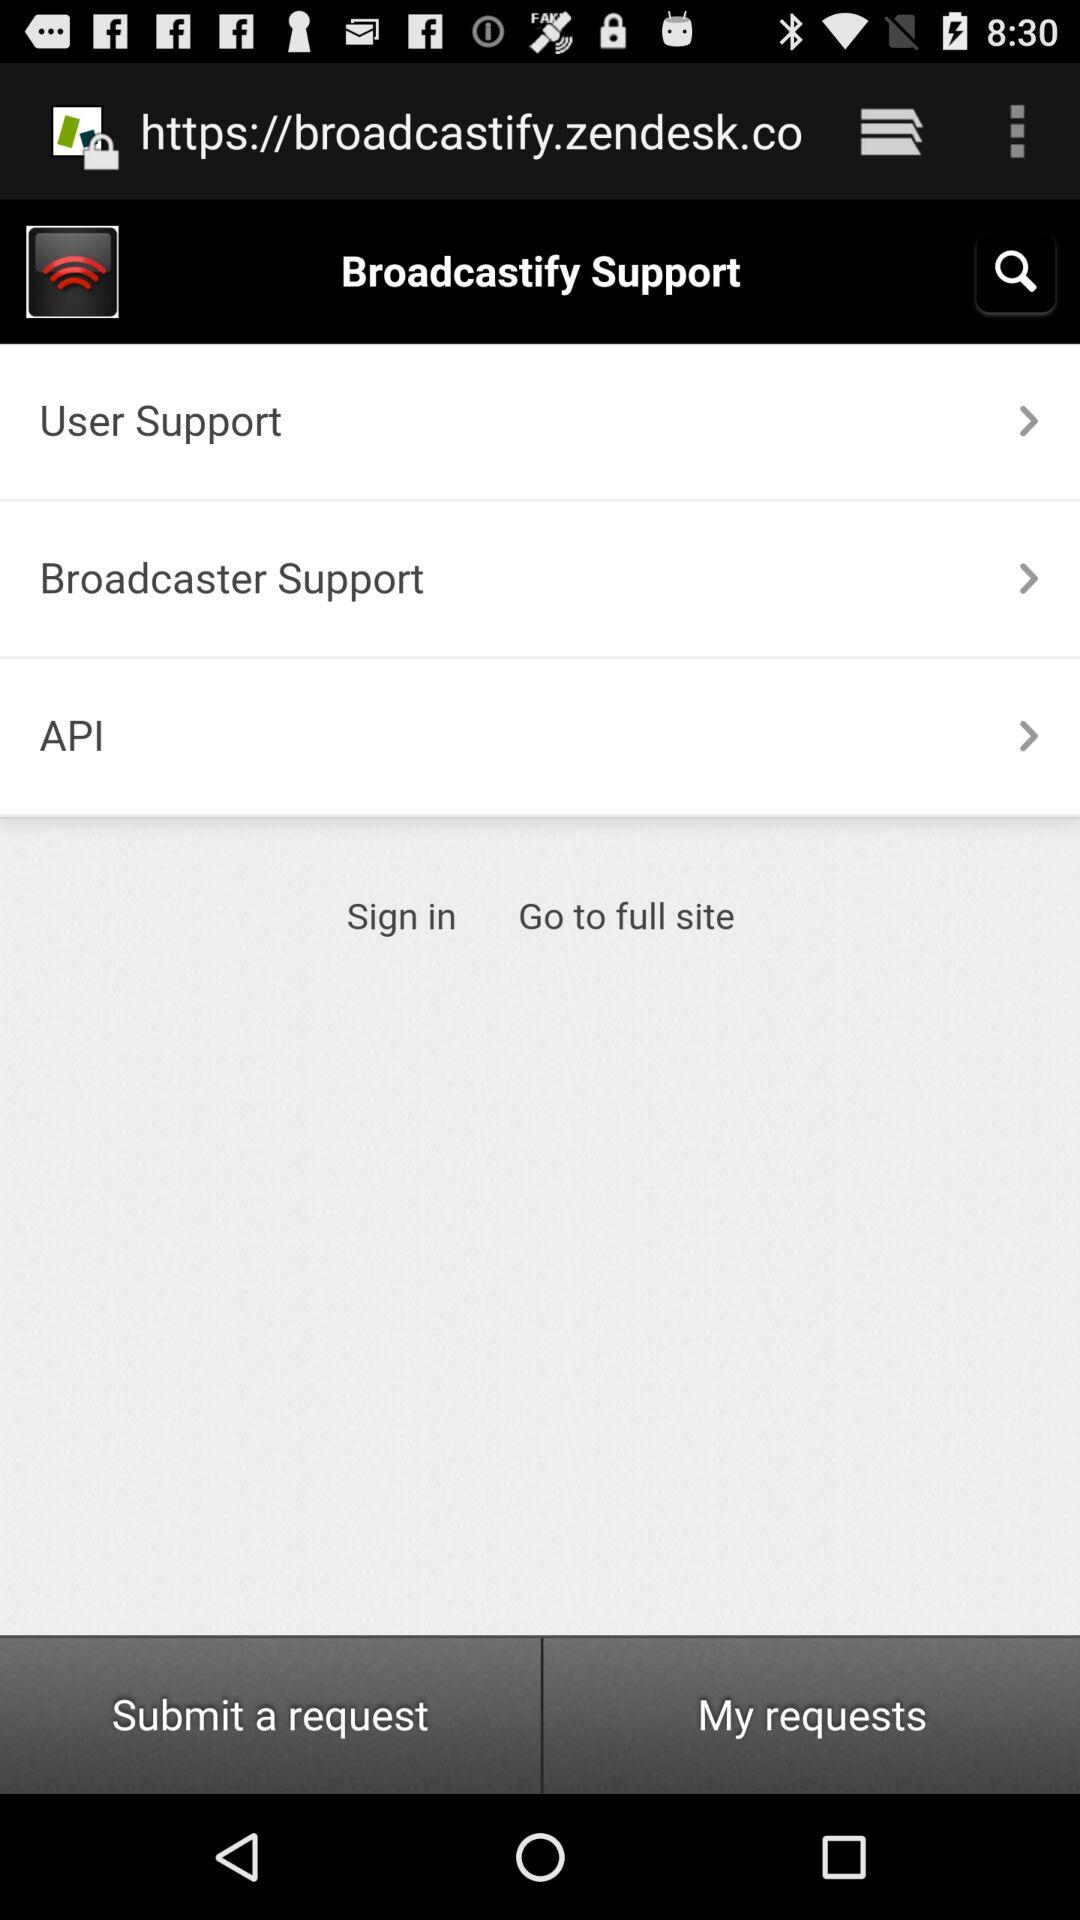When was the last request submitted?
When the provided information is insufficient, respond with <no answer>. <no answer> 